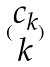<formula> <loc_0><loc_0><loc_500><loc_500>( \begin{matrix} c _ { k } \\ k \end{matrix} )</formula> 